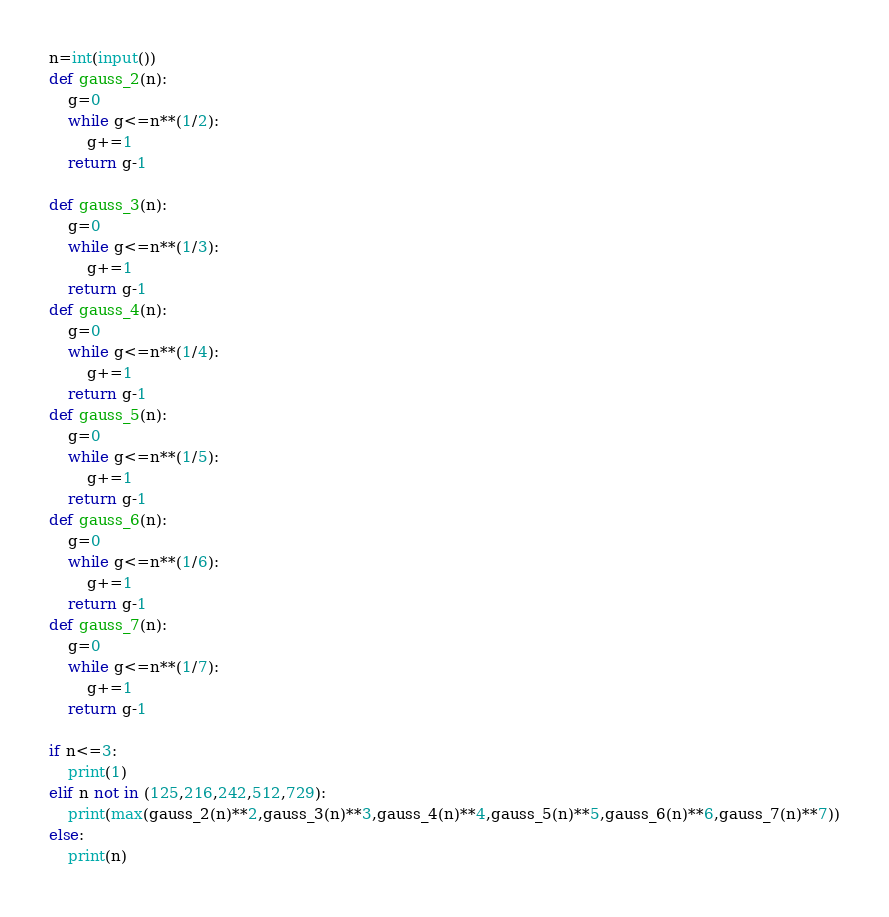<code> <loc_0><loc_0><loc_500><loc_500><_Python_>n=int(input())
def gauss_2(n):
    g=0
    while g<=n**(1/2):
        g+=1
    return g-1

def gauss_3(n):
    g=0
    while g<=n**(1/3):
        g+=1
    return g-1
def gauss_4(n):
    g=0
    while g<=n**(1/4):
        g+=1
    return g-1
def gauss_5(n):
    g=0
    while g<=n**(1/5):
        g+=1
    return g-1
def gauss_6(n):
    g=0
    while g<=n**(1/6):
        g+=1
    return g-1
def gauss_7(n):
    g=0
    while g<=n**(1/7):
        g+=1
    return g-1

if n<=3:
    print(1)
elif n not in (125,216,242,512,729):
    print(max(gauss_2(n)**2,gauss_3(n)**3,gauss_4(n)**4,gauss_5(n)**5,gauss_6(n)**6,gauss_7(n)**7))
else:
    print(n)</code> 